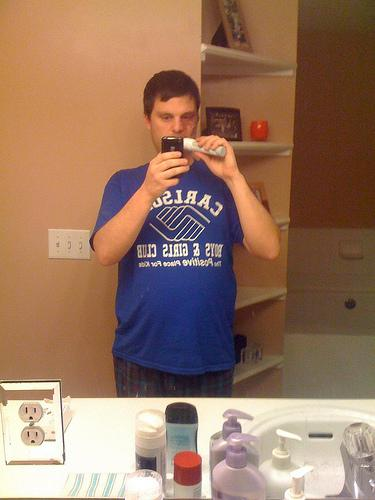Question: where is this taken?
Choices:
A. Bathroom.
B. Bedroom.
C. Living Room.
D. Dining Room.
Answer with the letter. Answer: A Question: what bright color is on the 2nd shelf?
Choices:
A. Red.
B. Purple.
C. Yellow.
D. Orange.
Answer with the letter. Answer: D Question: what is on the mirror to the left?
Choices:
A. Photo.
B. Crack.
C. Frame.
D. Outlet.
Answer with the letter. Answer: D Question: who is taking the photo?
Choices:
A. Woman.
B. Man.
C. The person in the mirror.
D. Girl.
Answer with the letter. Answer: C Question: how many light switches are there?
Choices:
A. One.
B. Two.
C. Four.
D. Three.
Answer with the letter. Answer: D 